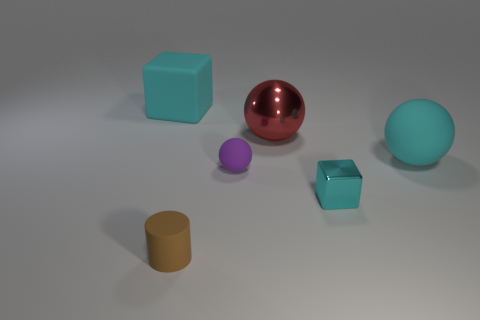Subtract all matte balls. How many balls are left? 1 Add 3 large blue rubber balls. How many objects exist? 9 Subtract all blocks. How many objects are left? 4 Subtract all gray spheres. Subtract all gray cubes. How many spheres are left? 3 Subtract all small purple matte spheres. Subtract all brown rubber cylinders. How many objects are left? 4 Add 5 big cyan rubber spheres. How many big cyan rubber spheres are left? 6 Add 4 small cylinders. How many small cylinders exist? 5 Subtract 0 green cubes. How many objects are left? 6 